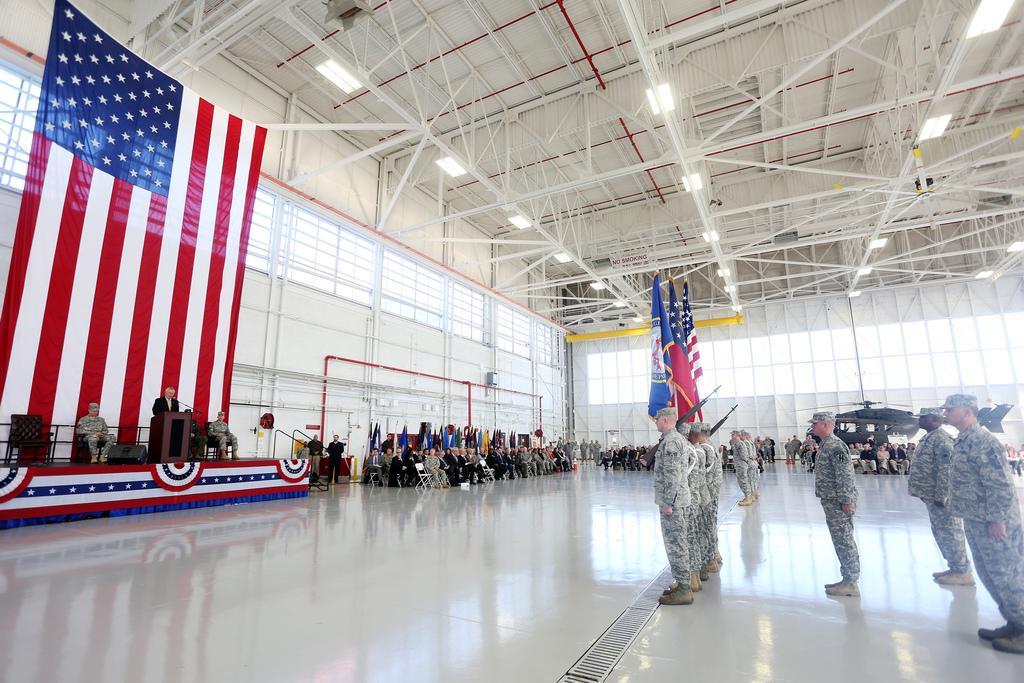In one or two sentences, can you explain what this image depicts? In this image we can see a few people, among them, one person is standing in front of the podium, on the podium, we can see a mic, there are some flags, guns, chairs and some other objects, at the top we can see some lights and metal rods. 